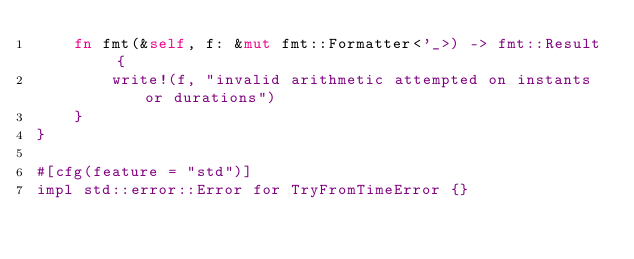<code> <loc_0><loc_0><loc_500><loc_500><_Rust_>    fn fmt(&self, f: &mut fmt::Formatter<'_>) -> fmt::Result {
        write!(f, "invalid arithmetic attempted on instants or durations")
    }
}

#[cfg(feature = "std")]
impl std::error::Error for TryFromTimeError {}
</code> 